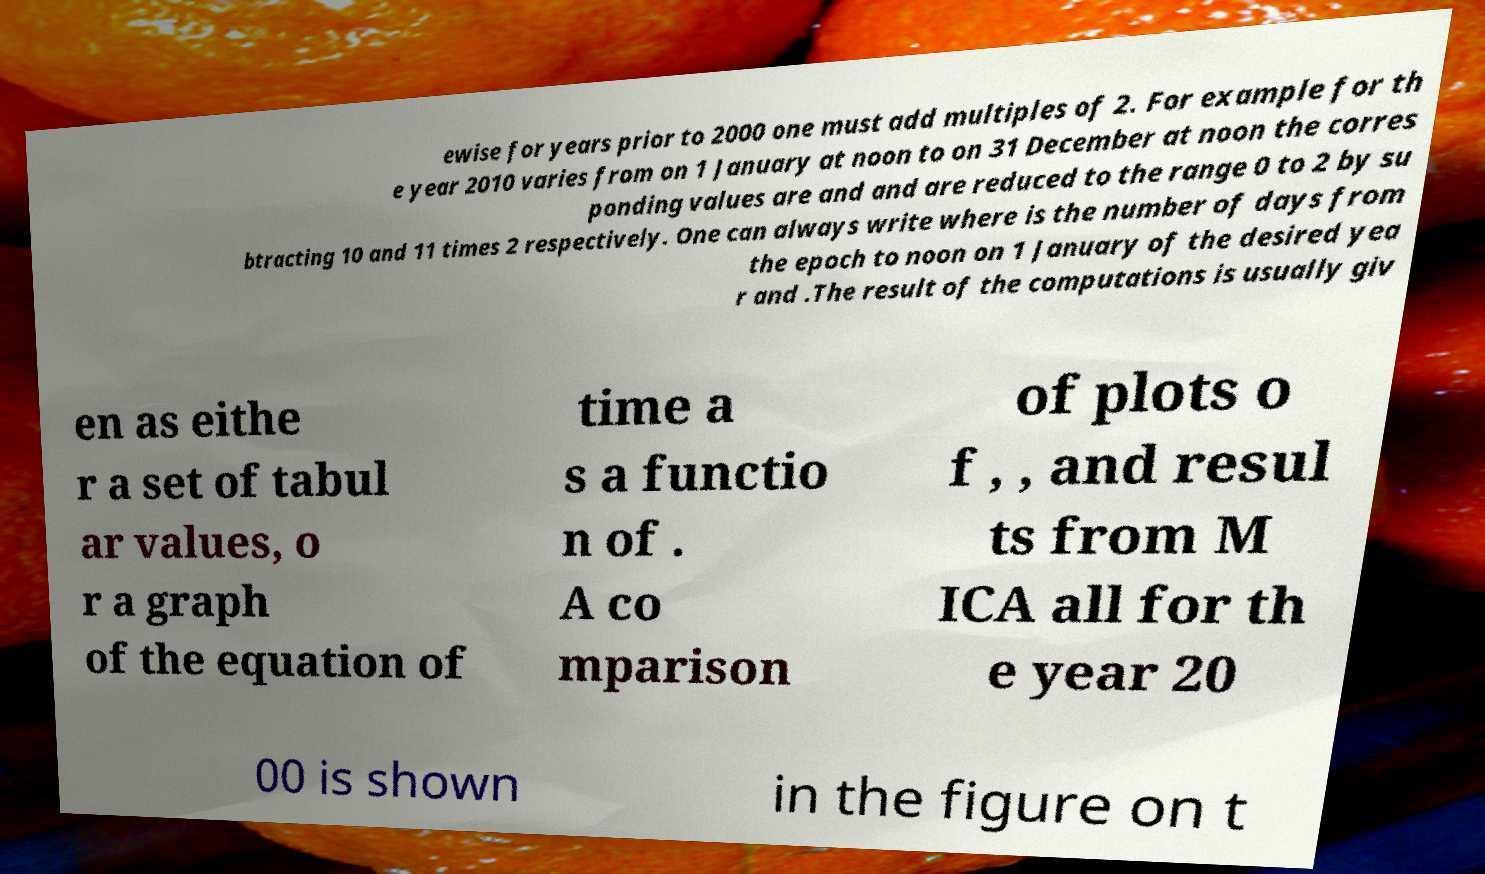For documentation purposes, I need the text within this image transcribed. Could you provide that? ewise for years prior to 2000 one must add multiples of 2. For example for th e year 2010 varies from on 1 January at noon to on 31 December at noon the corres ponding values are and and are reduced to the range 0 to 2 by su btracting 10 and 11 times 2 respectively. One can always write where is the number of days from the epoch to noon on 1 January of the desired yea r and .The result of the computations is usually giv en as eithe r a set of tabul ar values, o r a graph of the equation of time a s a functio n of . A co mparison of plots o f , , and resul ts from M ICA all for th e year 20 00 is shown in the figure on t 